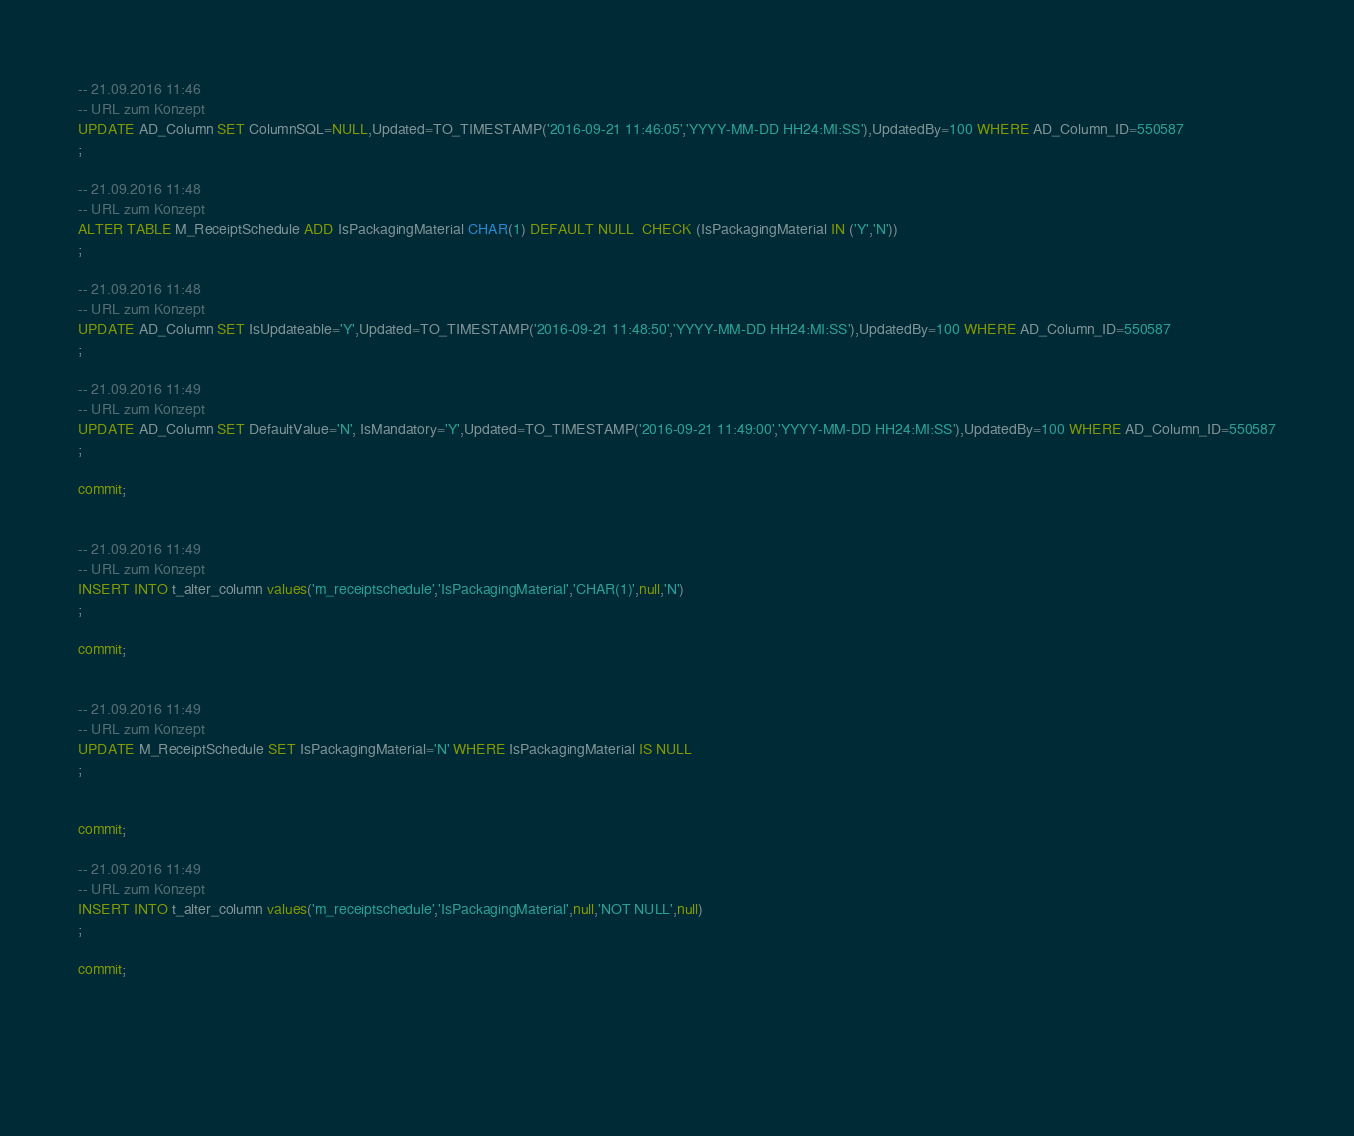Convert code to text. <code><loc_0><loc_0><loc_500><loc_500><_SQL_>-- 21.09.2016 11:46
-- URL zum Konzept
UPDATE AD_Column SET ColumnSQL=NULL,Updated=TO_TIMESTAMP('2016-09-21 11:46:05','YYYY-MM-DD HH24:MI:SS'),UpdatedBy=100 WHERE AD_Column_ID=550587
;

-- 21.09.2016 11:48
-- URL zum Konzept
ALTER TABLE M_ReceiptSchedule ADD IsPackagingMaterial CHAR(1) DEFAULT NULL  CHECK (IsPackagingMaterial IN ('Y','N'))
;

-- 21.09.2016 11:48
-- URL zum Konzept
UPDATE AD_Column SET IsUpdateable='Y',Updated=TO_TIMESTAMP('2016-09-21 11:48:50','YYYY-MM-DD HH24:MI:SS'),UpdatedBy=100 WHERE AD_Column_ID=550587
;

-- 21.09.2016 11:49
-- URL zum Konzept
UPDATE AD_Column SET DefaultValue='N', IsMandatory='Y',Updated=TO_TIMESTAMP('2016-09-21 11:49:00','YYYY-MM-DD HH24:MI:SS'),UpdatedBy=100 WHERE AD_Column_ID=550587
;

commit; 


-- 21.09.2016 11:49
-- URL zum Konzept
INSERT INTO t_alter_column values('m_receiptschedule','IsPackagingMaterial','CHAR(1)',null,'N')
;

commit;


-- 21.09.2016 11:49
-- URL zum Konzept
UPDATE M_ReceiptSchedule SET IsPackagingMaterial='N' WHERE IsPackagingMaterial IS NULL
;


commit;

-- 21.09.2016 11:49
-- URL zum Konzept
INSERT INTO t_alter_column values('m_receiptschedule','IsPackagingMaterial',null,'NOT NULL',null)
;

commit;


	
	</code> 